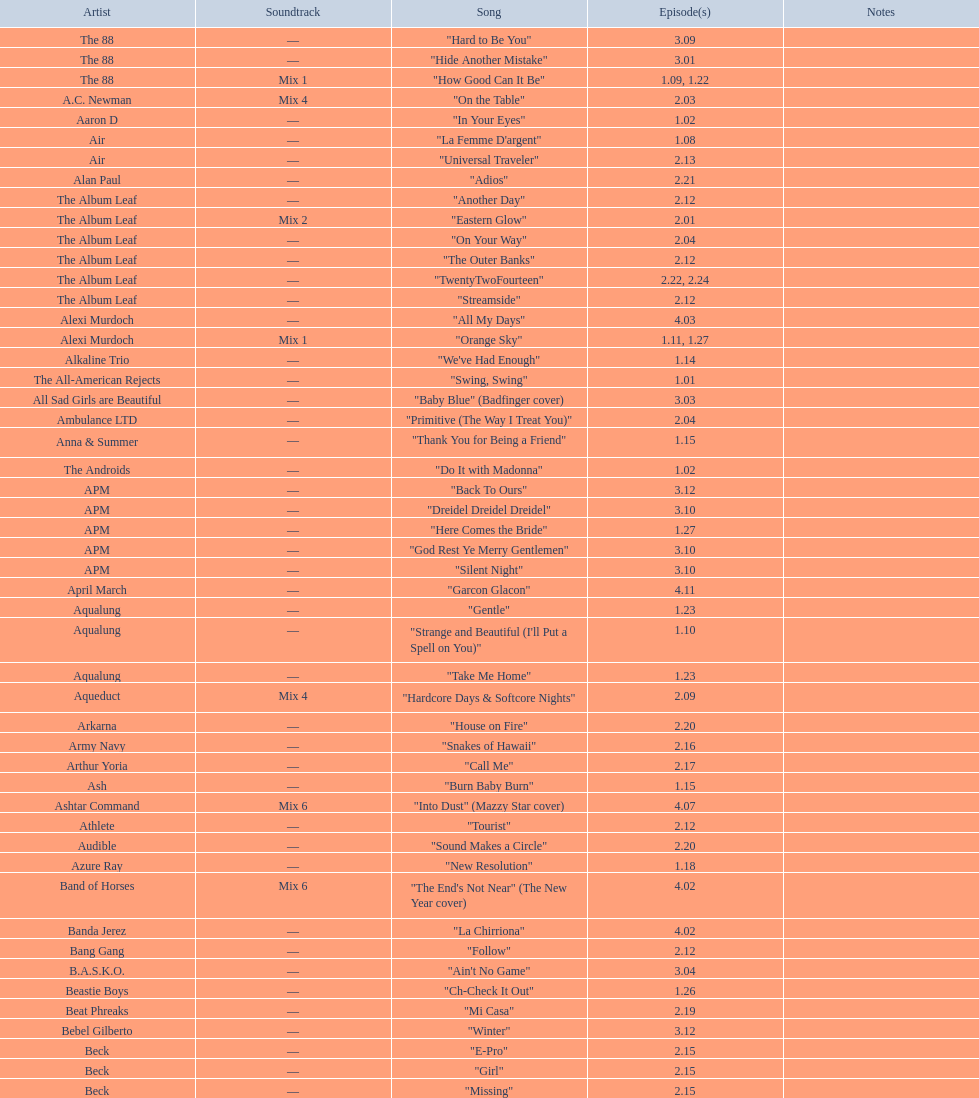How many consecutive songs were by the album leaf? 6. 